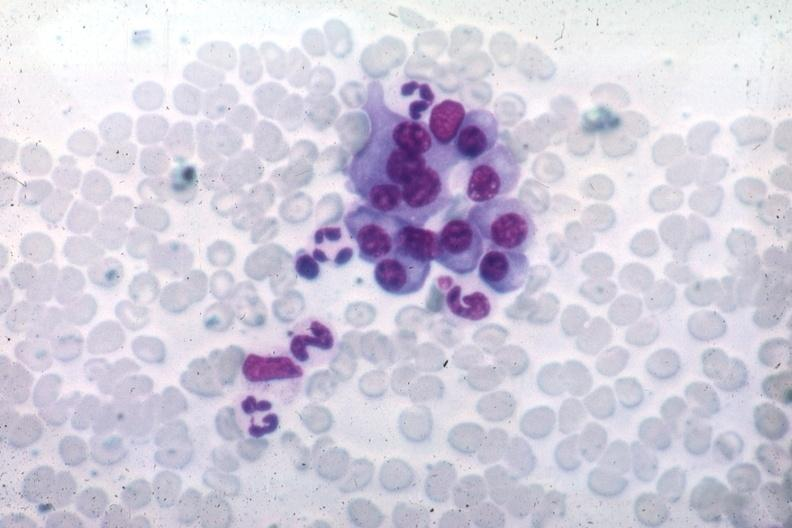what is wrights typical well differentiated?
Answer the question using a single word or phrase. Plasma cells source unknown 